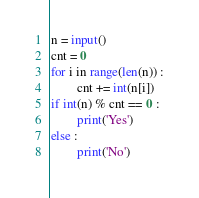<code> <loc_0><loc_0><loc_500><loc_500><_Python_>n = input()
cnt = 0
for i in range(len(n)) :
        cnt += int(n[i])
if int(n) % cnt == 0 :
        print('Yes')
else :
        print('No')</code> 